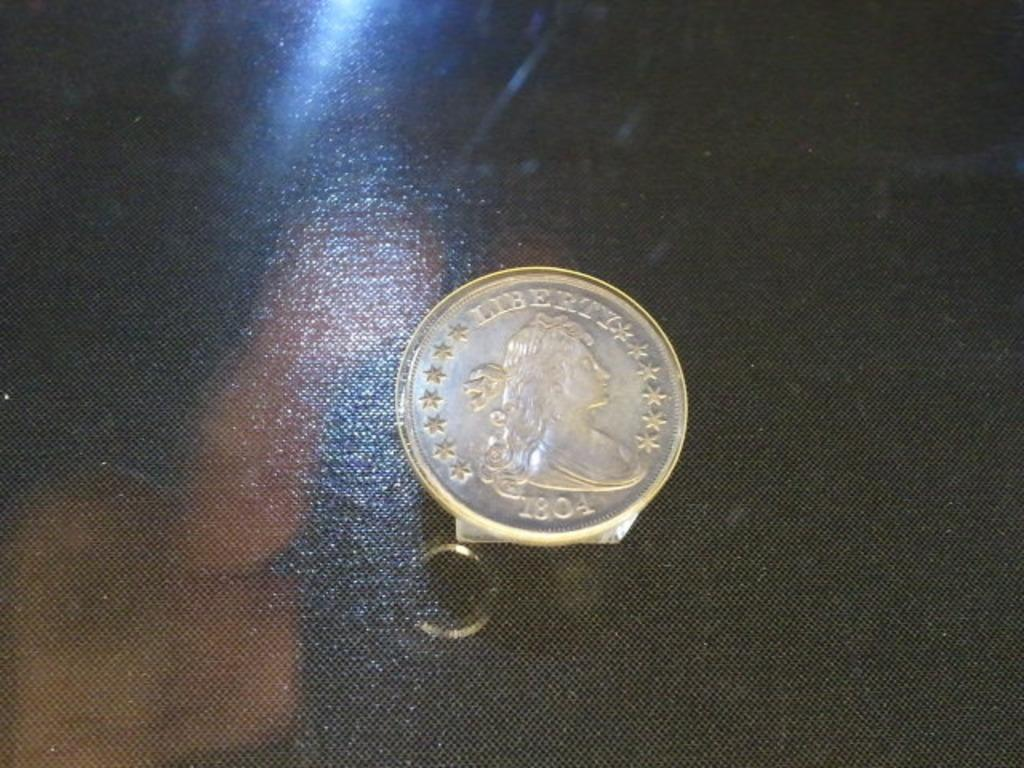<image>
Summarize the visual content of the image. A coin from 1804 is marked with the word "liberty" 